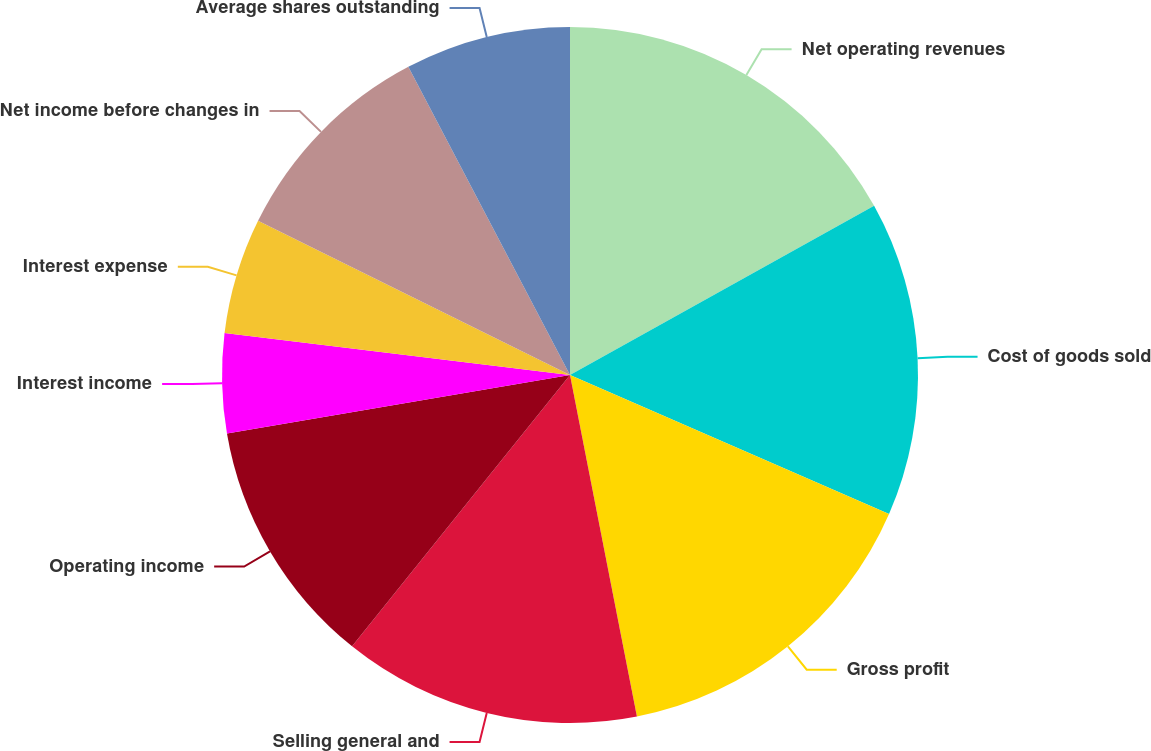Convert chart to OTSL. <chart><loc_0><loc_0><loc_500><loc_500><pie_chart><fcel>Net operating revenues<fcel>Cost of goods sold<fcel>Gross profit<fcel>Selling general and<fcel>Operating income<fcel>Interest income<fcel>Interest expense<fcel>Net income before changes in<fcel>Average shares outstanding<nl><fcel>16.92%<fcel>14.62%<fcel>15.38%<fcel>13.85%<fcel>11.54%<fcel>4.62%<fcel>5.38%<fcel>10.0%<fcel>7.69%<nl></chart> 